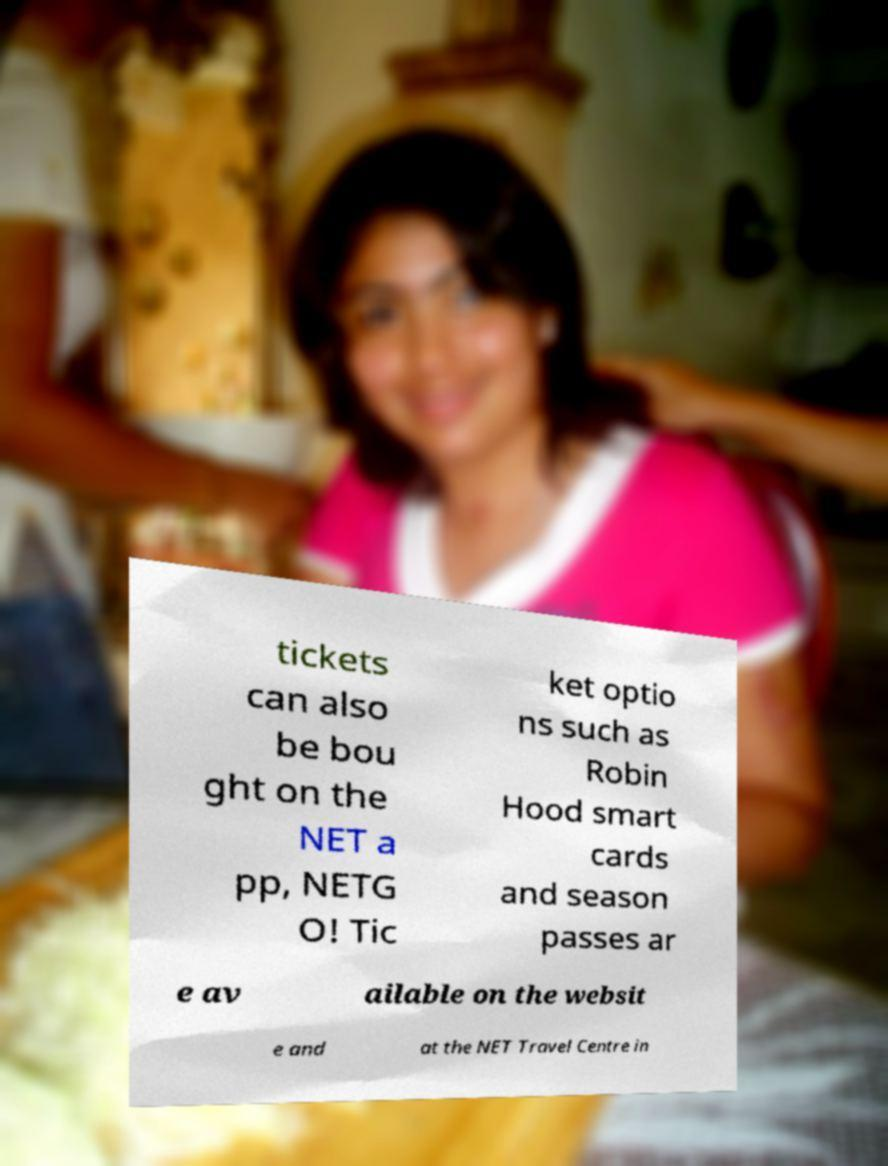Please read and relay the text visible in this image. What does it say? tickets can also be bou ght on the NET a pp, NETG O! Tic ket optio ns such as Robin Hood smart cards and season passes ar e av ailable on the websit e and at the NET Travel Centre in 